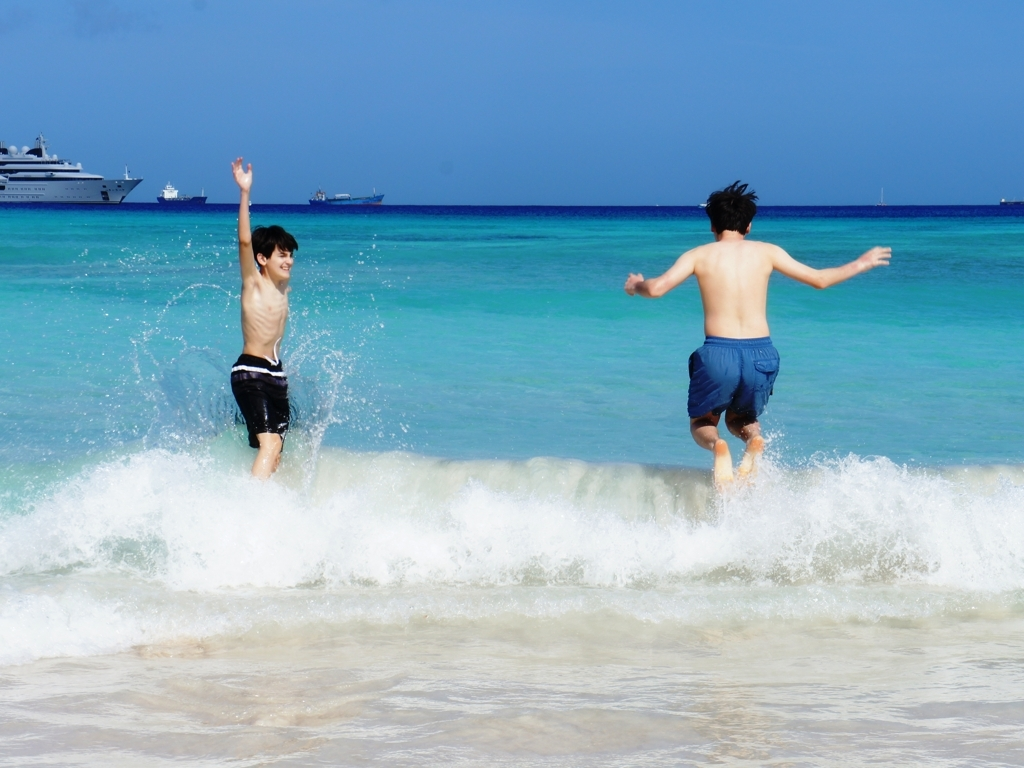Can you describe the environment around the subjects? Certainly! The photo captures a vivid beach scene with crystal-clear blue waters and a pale sandy shore. Several ships are in the distance under a clear sky, indicating that this beach may be near a popular sea route or anchorage. 